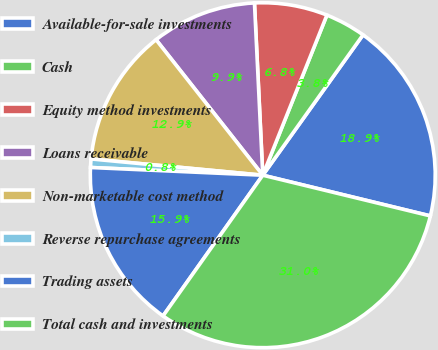Convert chart to OTSL. <chart><loc_0><loc_0><loc_500><loc_500><pie_chart><fcel>Available-for-sale investments<fcel>Cash<fcel>Equity method investments<fcel>Loans receivable<fcel>Non-marketable cost method<fcel>Reverse repurchase agreements<fcel>Trading assets<fcel>Total cash and investments<nl><fcel>18.92%<fcel>3.81%<fcel>6.83%<fcel>9.85%<fcel>12.88%<fcel>0.79%<fcel>15.9%<fcel>31.02%<nl></chart> 